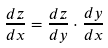Convert formula to latex. <formula><loc_0><loc_0><loc_500><loc_500>\frac { d z } { d x } = \frac { d z } { d y } \cdot \frac { d y } { d x }</formula> 